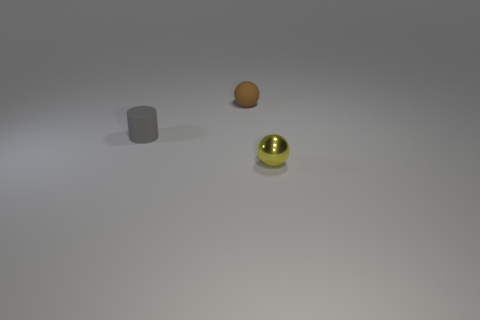Is there a ball that has the same color as the metal object?
Keep it short and to the point. No. Does the tiny yellow metal object have the same shape as the gray thing?
Give a very brief answer. No. What number of tiny objects are spheres or yellow matte cubes?
Your answer should be very brief. 2. There is a small ball that is made of the same material as the small gray object; what color is it?
Give a very brief answer. Brown. How many brown balls have the same material as the small gray object?
Keep it short and to the point. 1. Is the size of the sphere behind the yellow object the same as the sphere that is in front of the tiny cylinder?
Your response must be concise. Yes. What is the material of the tiny thing to the left of the sphere behind the tiny yellow shiny object?
Your response must be concise. Rubber. Are there fewer tiny metal objects behind the small gray rubber cylinder than tiny objects behind the tiny yellow shiny sphere?
Ensure brevity in your answer.  Yes. Is there any other thing that is the same shape as the metal thing?
Ensure brevity in your answer.  Yes. There is a yellow thing that is right of the gray cylinder; what material is it?
Your response must be concise. Metal. 